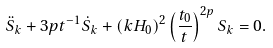<formula> <loc_0><loc_0><loc_500><loc_500>\ddot { S } _ { k } + 3 p t ^ { - 1 } \dot { S } _ { k } + \left ( k H _ { 0 } \right ) ^ { 2 } \left ( \frac { t _ { 0 } } { t } \right ) ^ { 2 p } S _ { k } = 0 .</formula> 